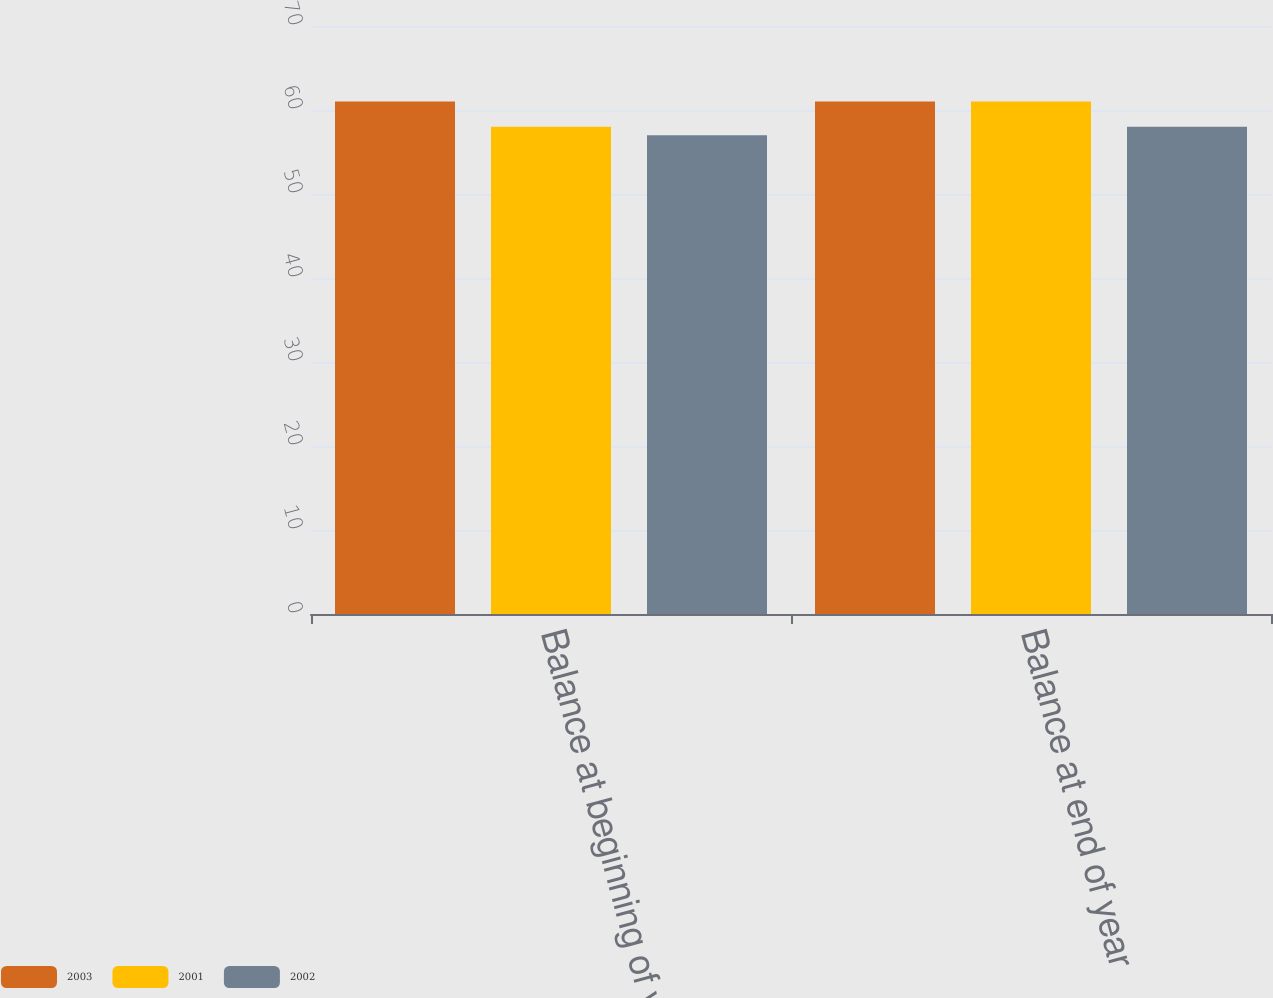<chart> <loc_0><loc_0><loc_500><loc_500><stacked_bar_chart><ecel><fcel>Balance at beginning of year<fcel>Balance at end of year<nl><fcel>2003<fcel>61<fcel>61<nl><fcel>2001<fcel>58<fcel>61<nl><fcel>2002<fcel>57<fcel>58<nl></chart> 